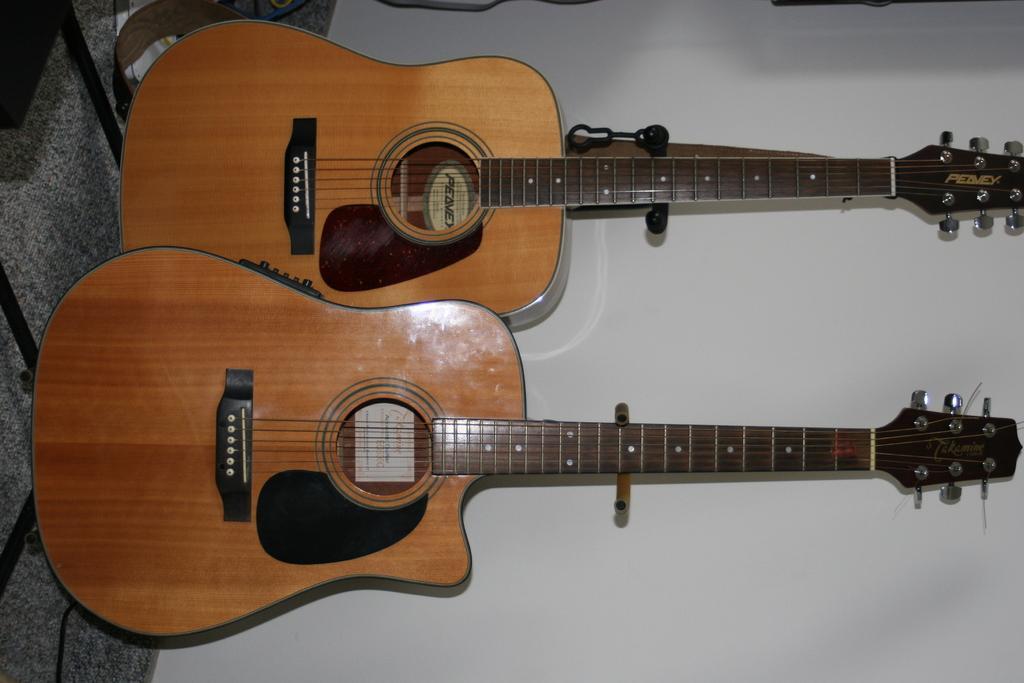Please provide a concise description of this image. As we can see in the image there are two guitars and a white color wall. 